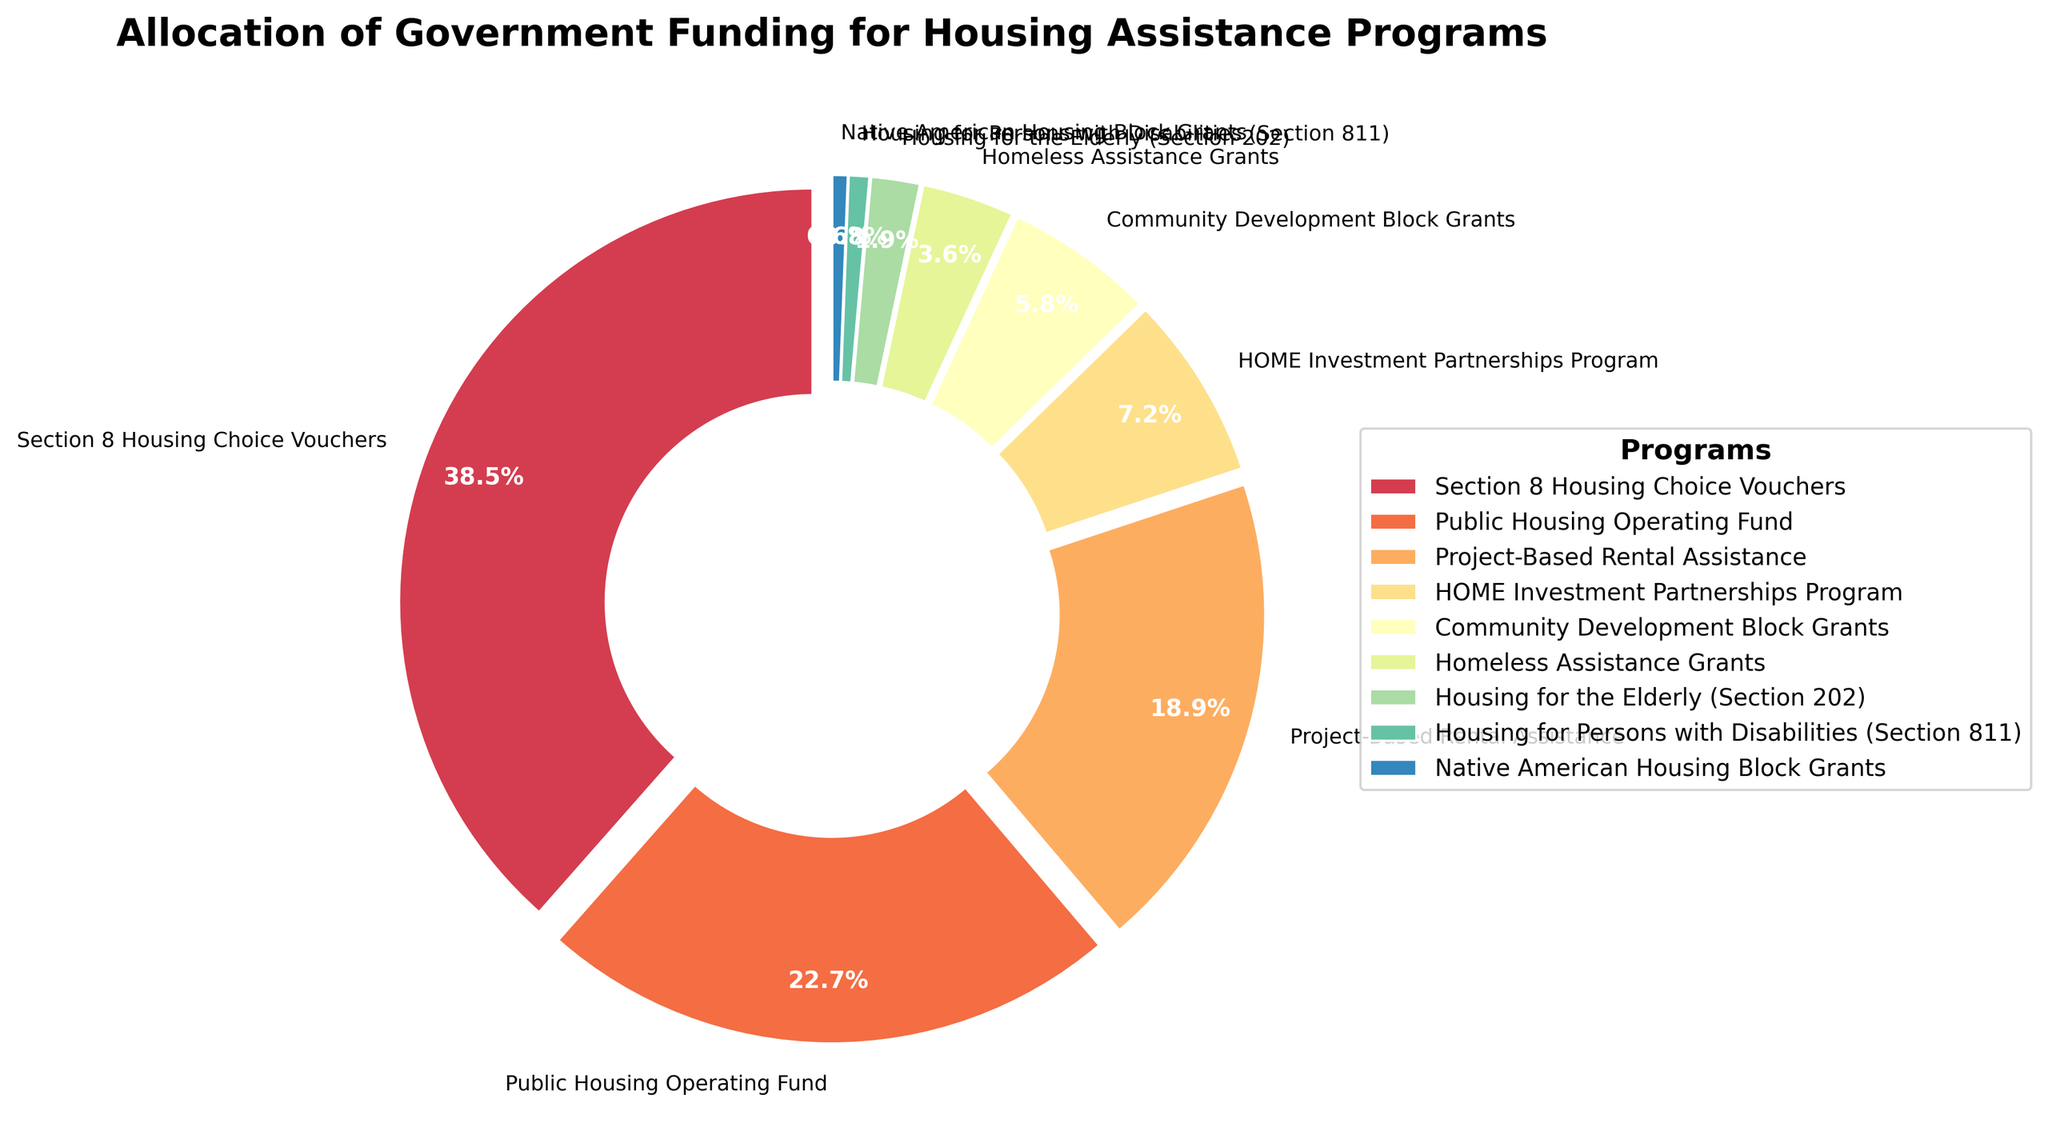Section Explanation
Answer: Answer Which program receives the largest share of funding? By visually inspecting the pie chart, the "Section 8 Housing Choice Vouchers" segment appears the largest. Cross-referencing percentages, it confirms 38.5%.
Answer: Section 8 Housing Choice Vouchers What is the combined funding allocation for Public Housing Operating Fund and Project-Based Rental Assistance? Adding the individual percentages of Public Housing Operating Fund (22.7%) and Project-Based Rental Assistance (18.9%): 22.7 + 18.9 = 41.6%
Answer: 41.6% How does the funding allocation for Community Development Block Grants compare to that of Homeless Assistance Grants? Community Development Block Grants (5.8%) have a greater percentage than Homeless Assistance Grants (3.6%).
Answer: Community Development Block Grants Which segment has visually the least proportion in the pie chart? The smallest wedge is visually represented by "Native American Housing Block Grants" at 0.6%.
Answer: Native American Housing Block Grants Is the funding allocated for Housing for the Elderly greater than that for Housing for Persons with Disabilities? Comparing the percentages: Housing for the Elderly (1.9%) is more than Housing for Persons with Disabilities (0.8%).
Answer: Yes What is the total percentage allocation for all programs listed? Adding all the listed percentages: 38.5 + 22.7 + 18.9 + 7.2 + 5.8 + 3.6 + 1.9 + 0.8 + 0.6 = 100%
Answer: 100% If the funding for Project-Based Rental Assistance is increased by 2%, what would its new funding allocation be? Current allocation for Project-Based Rental Assistance is 18.9%. Adding 2%: 18.9 + 2 = 20.9%
Answer: 20.9% Which program's share in the pie chart is almost double that of Community Development Block Grants? The percentage for Community Development Block Grants is 5.8%. Section 8 Housing Choice Vouchers (38.5%) remains almost seven times due to 38.5/5.8 ≈ 6.7.
Answer: Section 8 Housing Choice Vouchers 